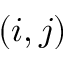Convert formula to latex. <formula><loc_0><loc_0><loc_500><loc_500>( i , j )</formula> 